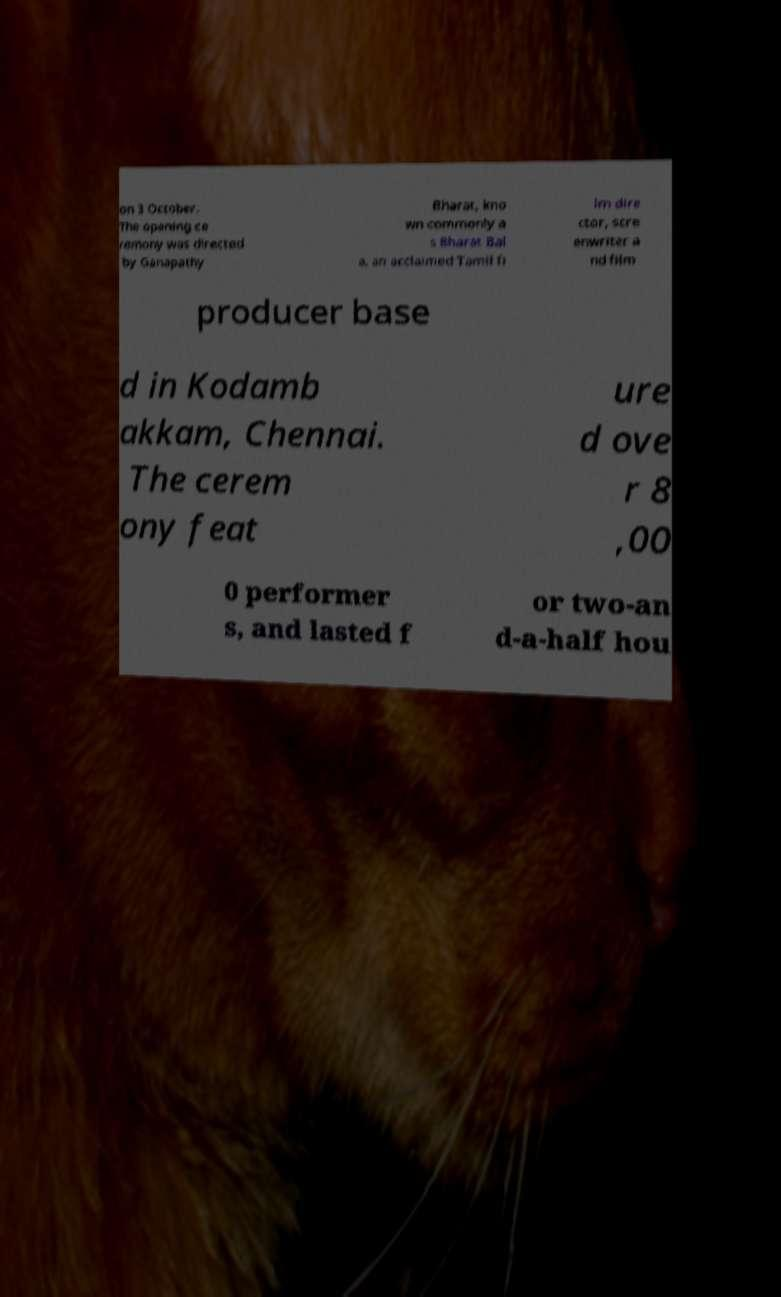Could you assist in decoding the text presented in this image and type it out clearly? on 3 October. The opening ce remony was directed by Ganapathy Bharat, kno wn commonly a s Bharat Bal a, an acclaimed Tamil fi lm dire ctor, scre enwriter a nd film producer base d in Kodamb akkam, Chennai. The cerem ony feat ure d ove r 8 ,00 0 performer s, and lasted f or two-an d-a-half hou 